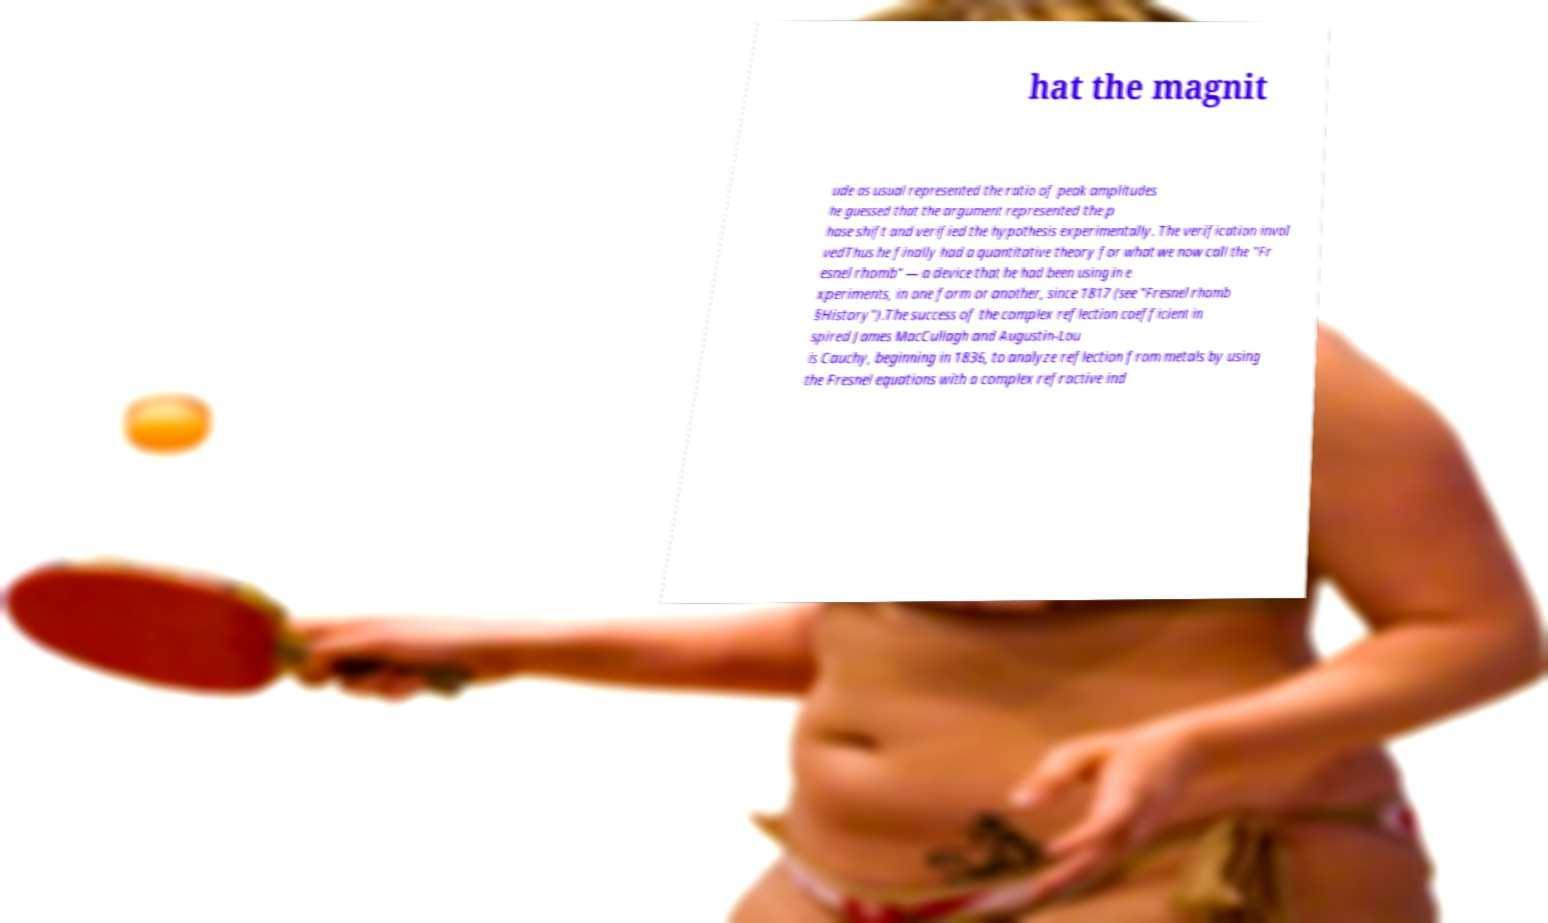For documentation purposes, I need the text within this image transcribed. Could you provide that? hat the magnit ude as usual represented the ratio of peak amplitudes he guessed that the argument represented the p hase shift and verified the hypothesis experimentally. The verification invol vedThus he finally had a quantitative theory for what we now call the "Fr esnel rhomb" — a device that he had been using in e xperiments, in one form or another, since 1817 (see "Fresnel rhomb §History").The success of the complex reflection coefficient in spired James MacCullagh and Augustin-Lou is Cauchy, beginning in 1836, to analyze reflection from metals by using the Fresnel equations with a complex refractive ind 